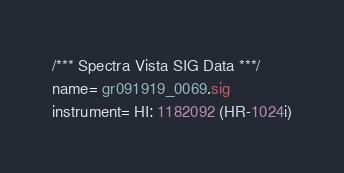Convert code to text. <code><loc_0><loc_0><loc_500><loc_500><_SML_>/*** Spectra Vista SIG Data ***/
name= gr091919_0069.sig
instrument= HI: 1182092 (HR-1024i)</code> 